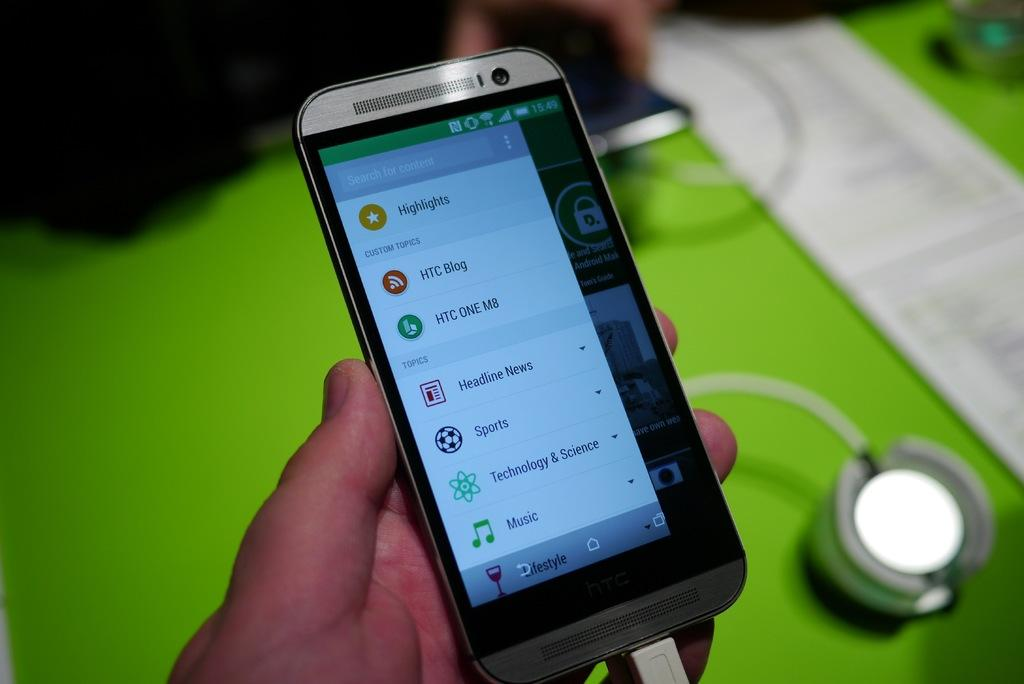Provide a one-sentence caption for the provided image. A person holds a smartphone showing a list of menu items such as sports and music. 